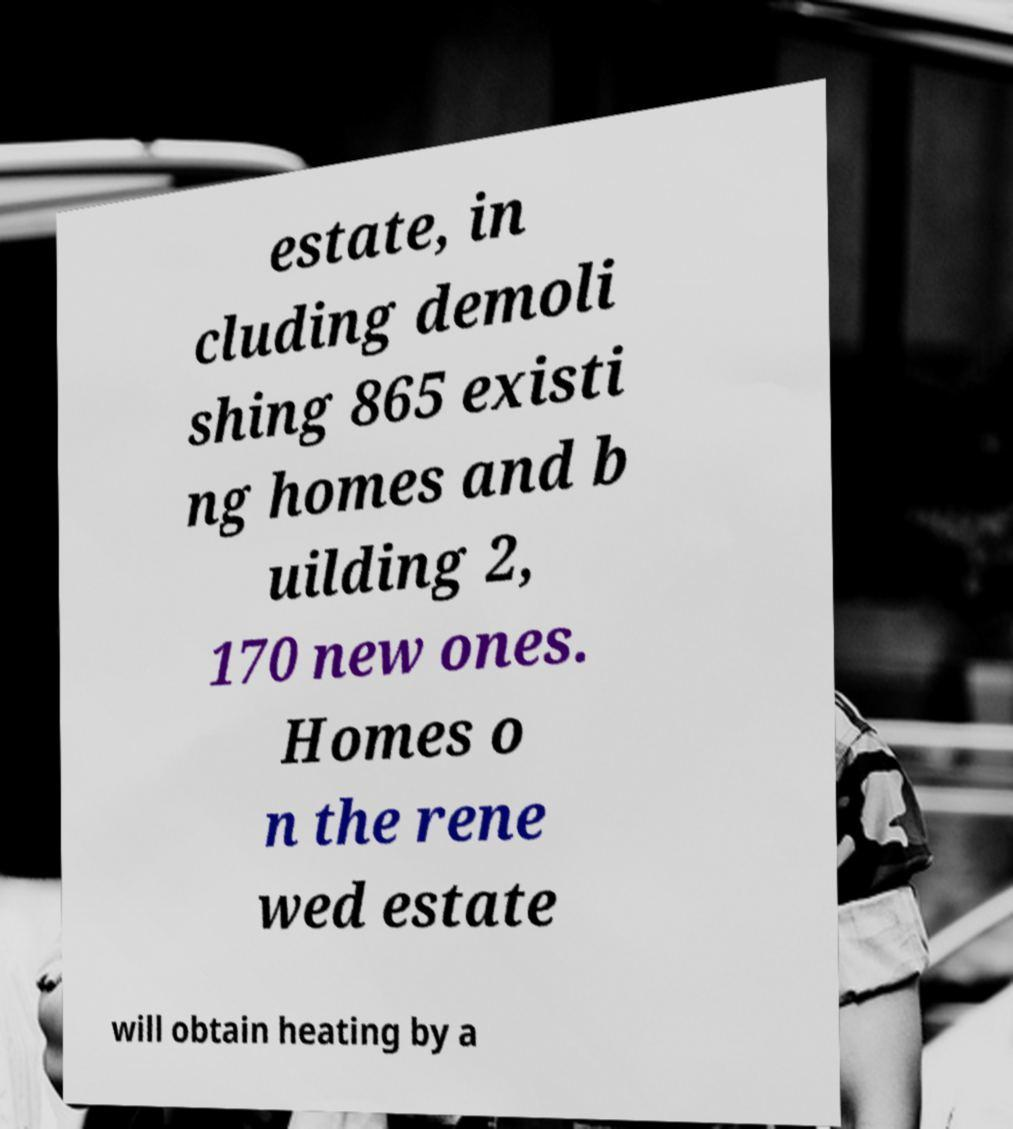Can you read and provide the text displayed in the image?This photo seems to have some interesting text. Can you extract and type it out for me? estate, in cluding demoli shing 865 existi ng homes and b uilding 2, 170 new ones. Homes o n the rene wed estate will obtain heating by a 